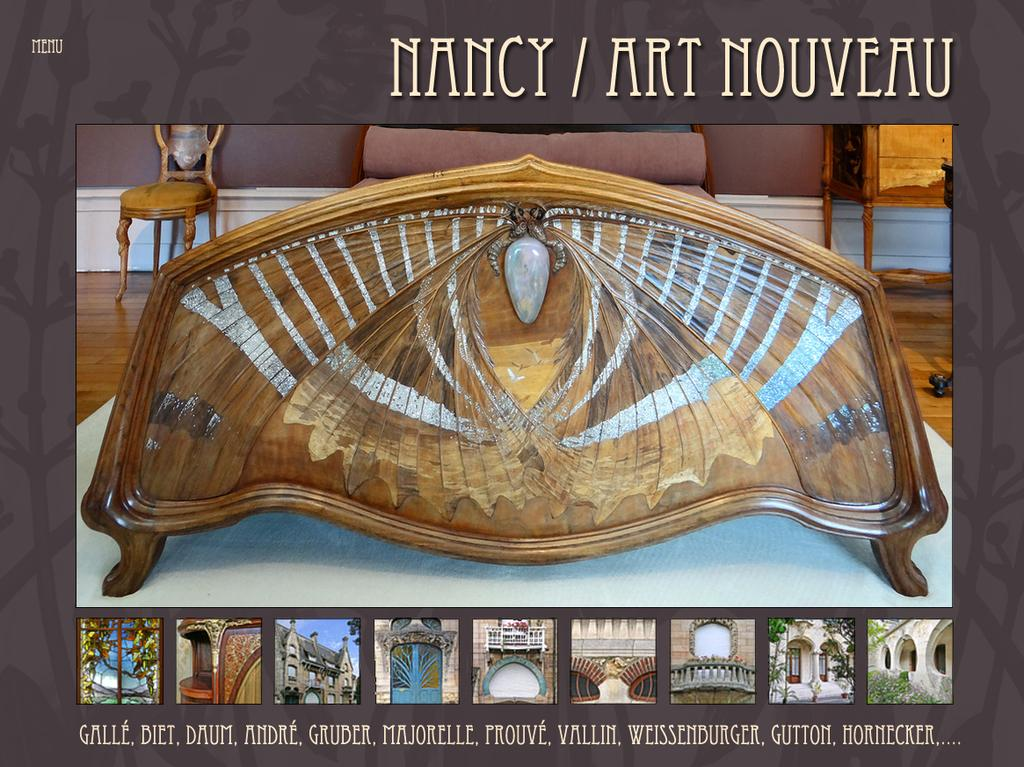What type of furniture is present in the image? There are chairs and tables in the image. What structures can be seen in the image? There are buildings in the image. What type of natural elements are visible in the image? There are trees in the image. What architectural feature is present in the image? There is a fence in the image. What type of openings can be seen in the buildings? There are windows in the image. What type of vegetation is present in the image? There are plants in the image. What type of written material is present in the image? There is text in the image. What part of the natural environment is visible in the image? The sky is visible in the image. How many beans are present in the image? There are no beans present in the image. What type of window is depicted in the image? There is no specific window depicted in the image; only windows in general are mentioned. What shape is the square in the image? There is no square present in the image. 